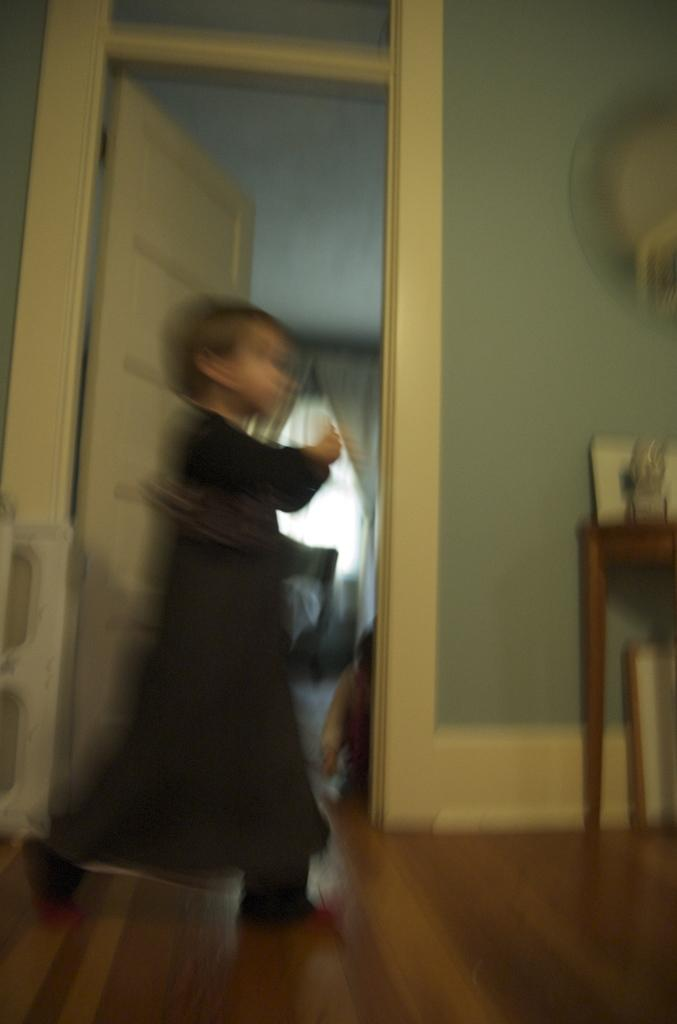Who is present in the image? There is a girl in the image. What type of architectural feature can be seen in the image? There is a door in the image. What type of structures surround the girl in the image? There are walls in the image. What type of furniture is present in the image? There is a table in the image. What type of window treatment is present in the image? There are curtains in the image. What other objects can be seen in the image? There are objects in the image. What type of pot is visible in the image? There is no pot present in the image. Can you tell me how many basketballs are visible in the image? There are no basketballs present in the image. 